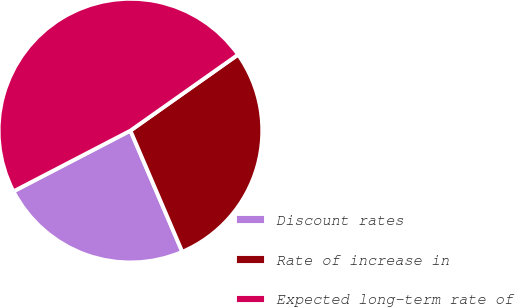Convert chart. <chart><loc_0><loc_0><loc_500><loc_500><pie_chart><fcel>Discount rates<fcel>Rate of increase in<fcel>Expected long-term rate of<nl><fcel>23.81%<fcel>28.35%<fcel>47.84%<nl></chart> 